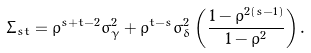Convert formula to latex. <formula><loc_0><loc_0><loc_500><loc_500>\Sigma _ { s t } = \rho ^ { s + t - 2 } \sigma ^ { 2 } _ { \gamma } + \rho ^ { t - s } \sigma ^ { 2 } _ { \delta } \left ( \frac { 1 - \rho ^ { 2 ( s - 1 ) } } { 1 - \rho ^ { 2 } } \right ) .</formula> 